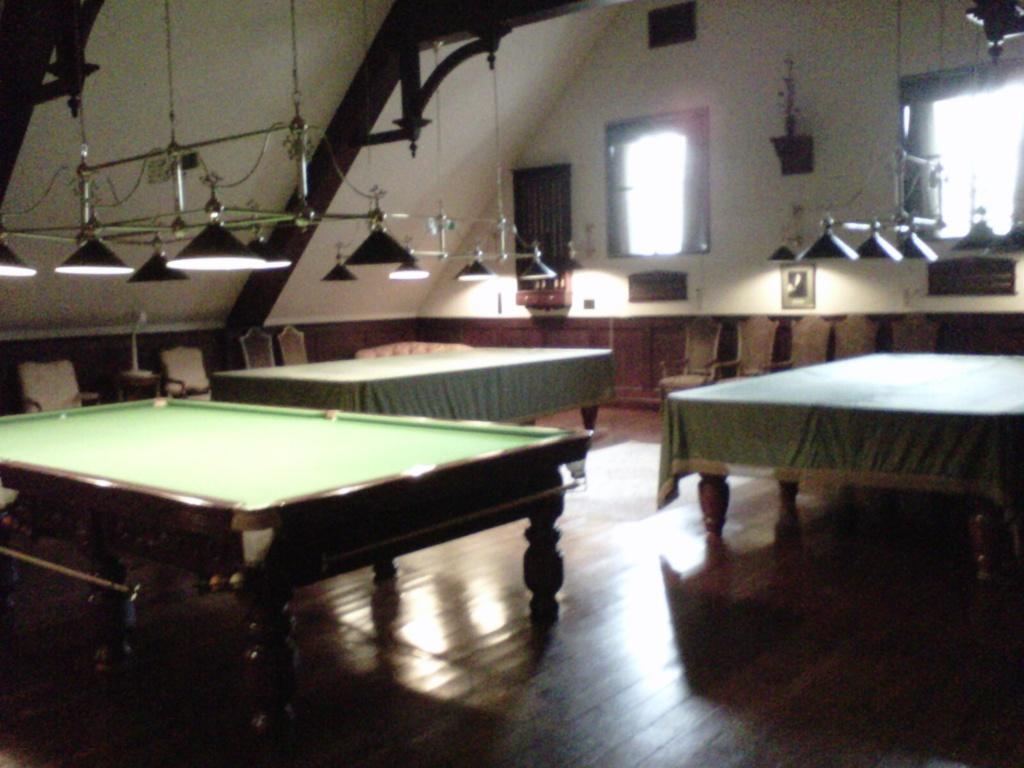Could you give a brief overview of what you see in this image? In this picture there are tables, snooker table, chairs and wooden floor. In the center of the picture there are lights. In the background there are windows and wall and there are wooden frames also. 